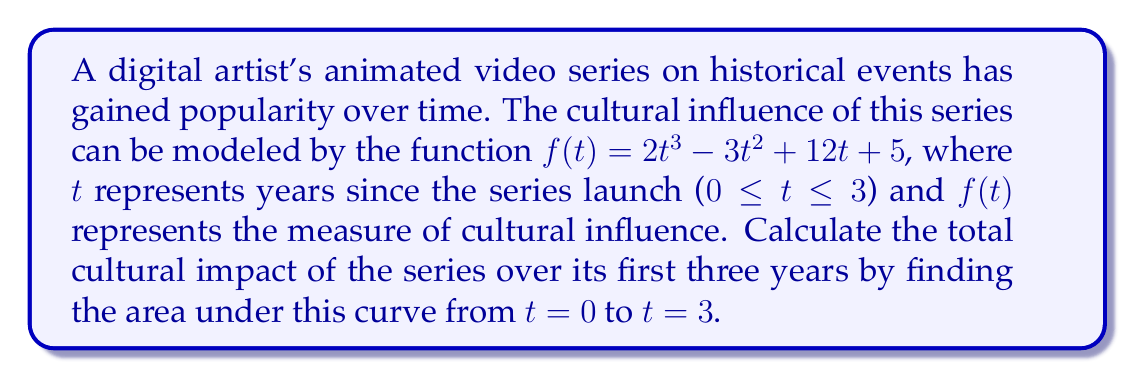Can you solve this math problem? To find the area under the curve, we need to calculate the definite integral of $f(t)$ from $t = 0$ to $t = 3$. Let's approach this step-by-step:

1) The function is $f(t) = 2t^3 - 3t^2 + 12t + 5$

2) We need to find $\int_0^3 f(t) dt$

3) Let's integrate each term:
   
   $$\int (2t^3 - 3t^2 + 12t + 5) dt = \frac{1}{2}t^4 - t^3 + 6t^2 + 5t + C$$

4) Now, we'll apply the definite integral:

   $$[\frac{1}{2}t^4 - t^3 + 6t^2 + 5t]_0^3$$

5) Evaluate at $t = 3$:
   
   $$\frac{1}{2}(3^4) - (3^3) + 6(3^2) + 5(3) = 40.5 - 27 + 54 + 15 = 82.5$$

6) Evaluate at $t = 0$:
   
   $$\frac{1}{2}(0^4) - (0^3) + 6(0^2) + 5(0) = 0$$

7) Subtract the results:

   $$82.5 - 0 = 82.5$$

Therefore, the total area under the curve, representing the cumulative cultural impact over three years, is 82.5 units.
Answer: 82.5 units 